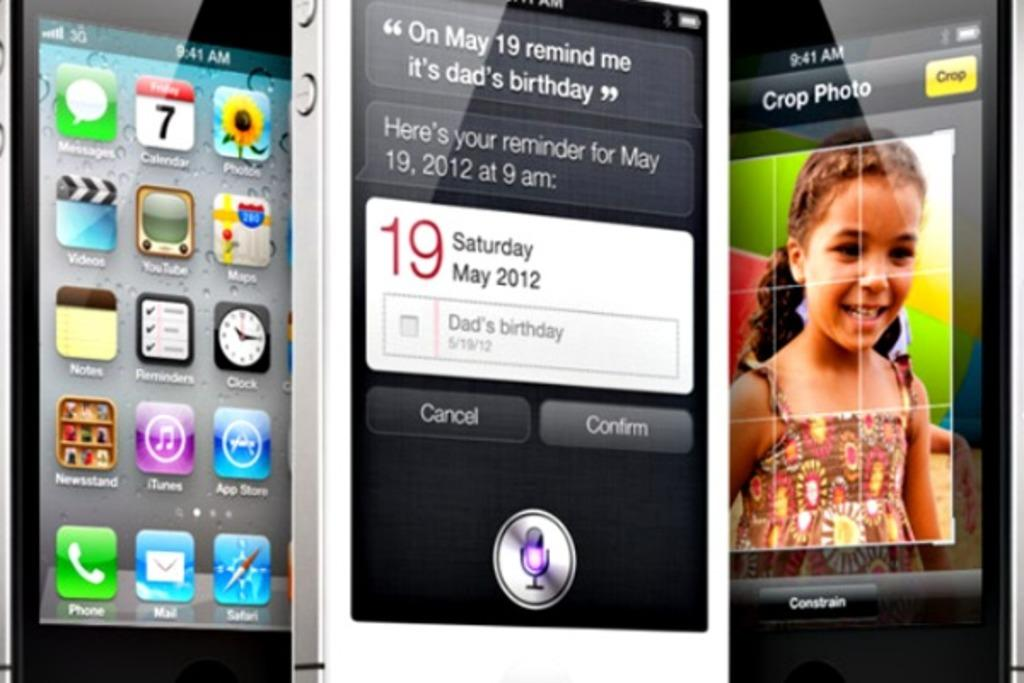<image>
Share a concise interpretation of the image provided. three phones in upright position , one in middle has a reminder for dads birthday on may 19 